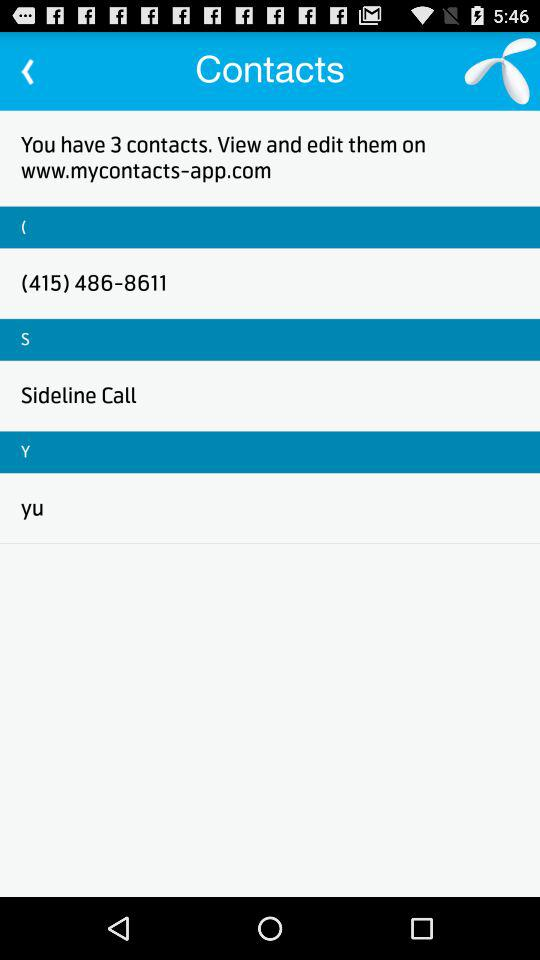What is the contact number? The contact number is (415) 486-8611. 